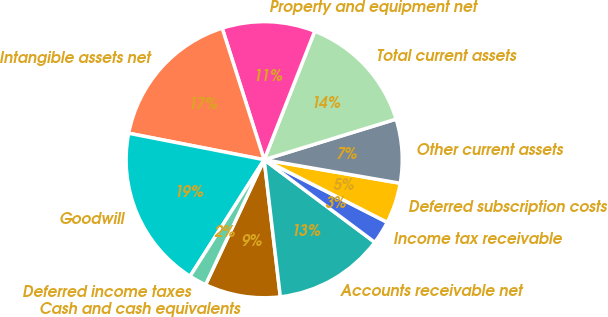Convert chart. <chart><loc_0><loc_0><loc_500><loc_500><pie_chart><fcel>Cash and cash equivalents<fcel>Accounts receivable net<fcel>Income tax receivable<fcel>Deferred subscription costs<fcel>Other current assets<fcel>Total current assets<fcel>Property and equipment net<fcel>Intangible assets net<fcel>Goodwill<fcel>Deferred income taxes<nl><fcel>8.84%<fcel>12.92%<fcel>2.72%<fcel>4.76%<fcel>7.48%<fcel>14.28%<fcel>10.88%<fcel>17.01%<fcel>19.05%<fcel>2.04%<nl></chart> 